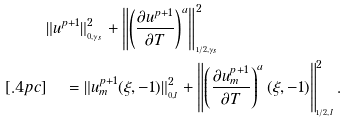Convert formula to latex. <formula><loc_0><loc_0><loc_500><loc_500>& \| u ^ { p + 1 } \| _ { _ { 0 , \gamma _ { s } } } ^ { 2 } + \left \| \left ( \frac { \partial u ^ { p + 1 } } { \partial T } \right ) ^ { a } \right \| _ { _ { 1 / 2 , \gamma _ { s } } } ^ { 2 } \\ [ . 4 p c ] & \quad \, = \| u _ { m } ^ { p + 1 } ( \xi , - 1 ) \| _ { _ { 0 , I } } ^ { 2 } + \left \| \left ( \frac { \partial u _ { m } ^ { p + 1 } } { \partial T } \right ) ^ { a } ( \xi , - 1 ) \right \| _ { _ { 1 / 2 , I } } ^ { 2 } .</formula> 